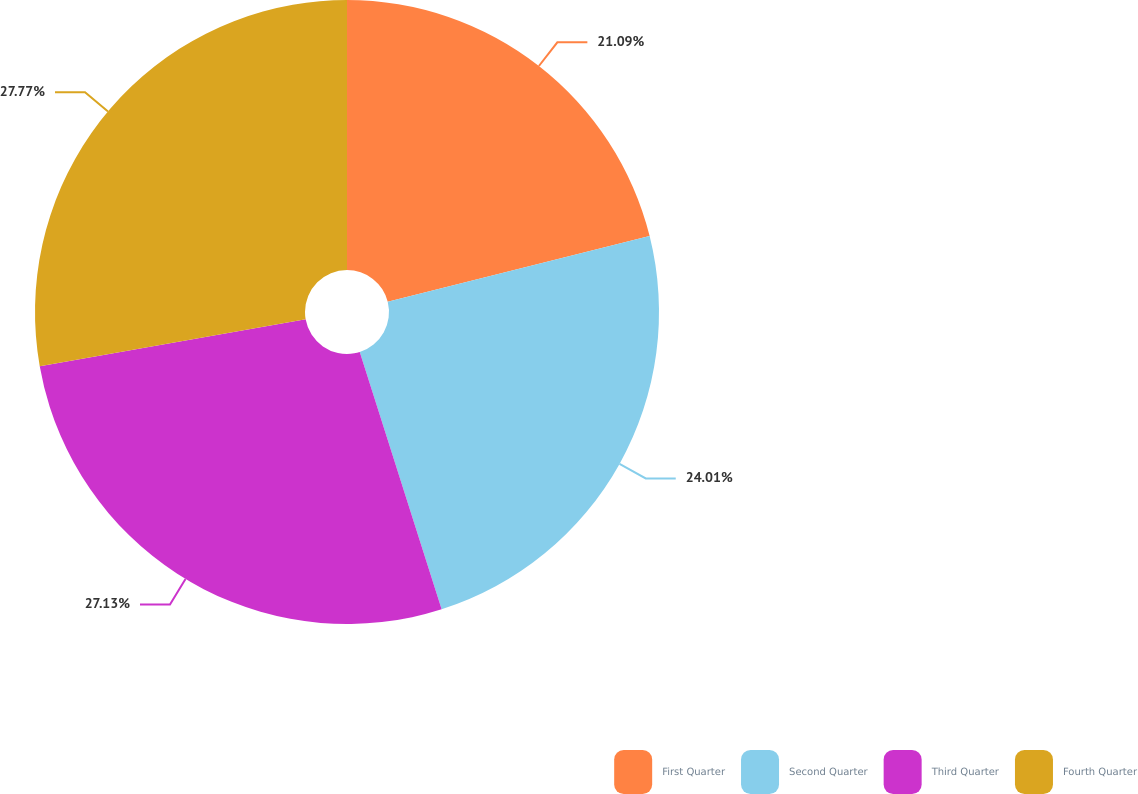<chart> <loc_0><loc_0><loc_500><loc_500><pie_chart><fcel>First Quarter<fcel>Second Quarter<fcel>Third Quarter<fcel>Fourth Quarter<nl><fcel>21.09%<fcel>24.01%<fcel>27.13%<fcel>27.78%<nl></chart> 